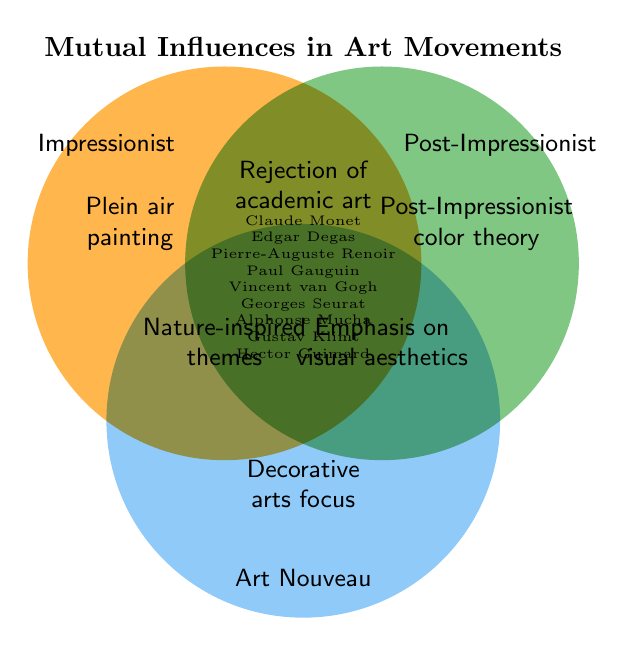What is the title of the Venn diagram? The title is typically located at the top of the figure. In this case, it's "Mutual Influences in Art Movements".
Answer: Mutual Influences in Art Movements Which art movement is represented by a color associated with nature? The color associated with nature in the diagram is a shade of green, representing the Post-Impressionist movement.
Answer: Post-Impressionist How many unique elements are shared among all three movements? In the intersection of all three circles, there are three elements: "Rejection of academic art", "Nature-inspired themes", and "Emphasis on visual aesthetics".
Answer: Three Which artist is shared between the Impressionist and Post-Impressionist movements but not Art Nouveau? In the diagram, the area where only the Impressionist and Post-Impressionist circles overlap includes "Paul Gauguin".
Answer: Paul Gauguin What element related to artistic techniques is unique to the Impressionist movement? In the part of the Venn diagram exclusive to Impressionists, "Plein air painting" is listed.
Answer: Plein air painting Compare the themes emphasized across all three movements. Which share a similar concept? By examining the overlaps, "Rejection of academic art" and "Nature-inspired themes" share a similar conceptual approach across all movements.
Answer: Rejection of academic art, Nature-inspired themes Which movement focuses on decorative arts according to the Venn diagram? The label "Decorative arts focus" is located within the Art Nouveau circle and is not shared with the other movements.
Answer: Art Nouveau What common elements blend Impressionist values with Art Nouveau aesthetics? The diagram shows that "Nature-inspired themes" are found between Impressionist and Art Nouveau areas.
Answer: Nature-inspired themes What distinctive symbol represents all shared traits among the movements? In the central part of the diagram where all circles overlap, we find that shared traits are expressed as unified but are not visualized by a specific symbol or distinctive item. We're referring to textual descriptions of shared traits.
Answer: No specific symbol 